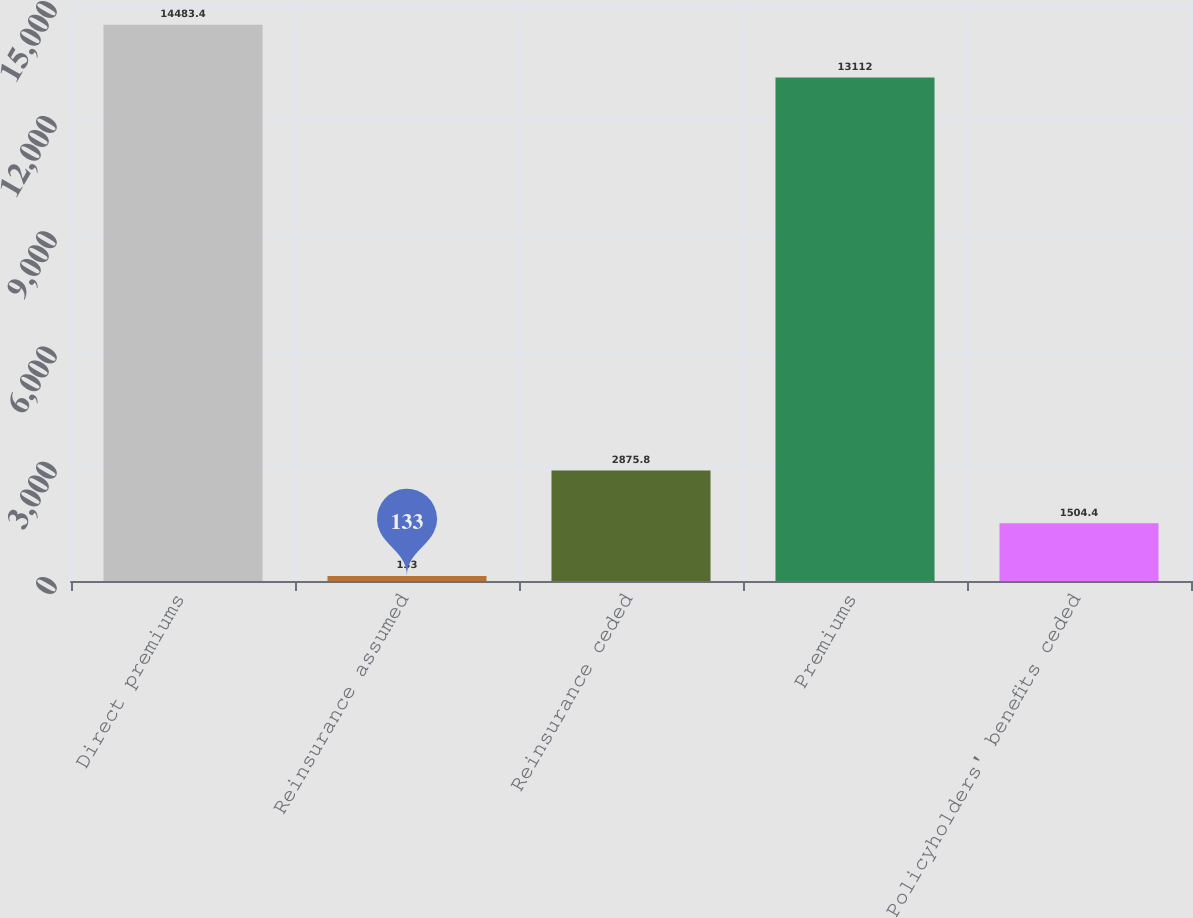Convert chart to OTSL. <chart><loc_0><loc_0><loc_500><loc_500><bar_chart><fcel>Direct premiums<fcel>Reinsurance assumed<fcel>Reinsurance ceded<fcel>Premiums<fcel>Policyholders' benefits ceded<nl><fcel>14483.4<fcel>133<fcel>2875.8<fcel>13112<fcel>1504.4<nl></chart> 